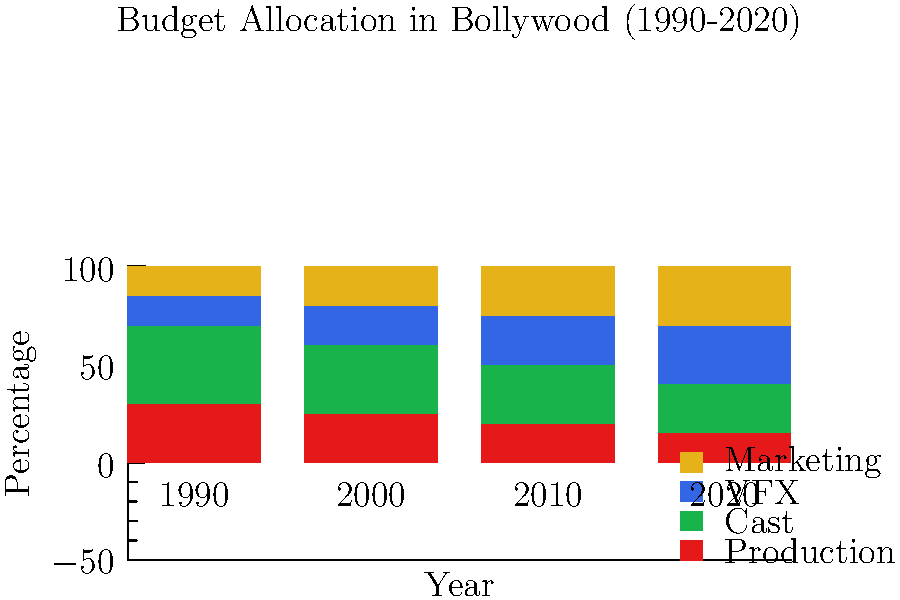Based on the stacked bar chart showing the budget allocation for different aspects of Bollywood film production from 1990 to 2020, which aspect has seen the most significant increase in its percentage share of the budget? To determine which aspect has seen the most significant increase in its percentage share of the budget, we need to compare the change in percentage for each aspect from 1990 to 2020:

1. Production:
   1990: 30%
   2020: 15%
   Change: -15% (decrease)

2. Cast:
   1990: 40%
   2020: 25%
   Change: -15% (decrease)

3. VFX (Visual Effects):
   1990: 15%
   2020: 30%
   Change: +15% (increase)

4. Marketing:
   1990: 15%
   2020: 30%
   Change: +15% (increase)

Both VFX and Marketing have seen the same increase of 15 percentage points. However, this represents a 100% increase for both (from 15% to 30%), which is the most significant increase among all aspects.
Answer: VFX and Marketing (tied) 